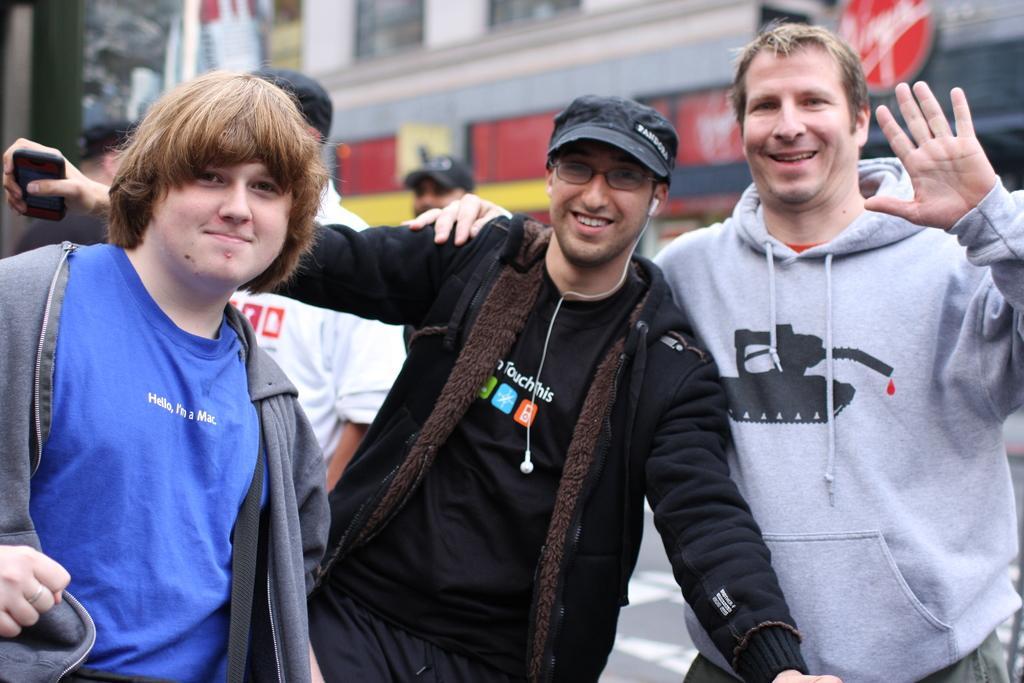How would you summarize this image in a sentence or two? In this image, I can see three persons standing and smiling. In the background, I can see a building and three persons. 